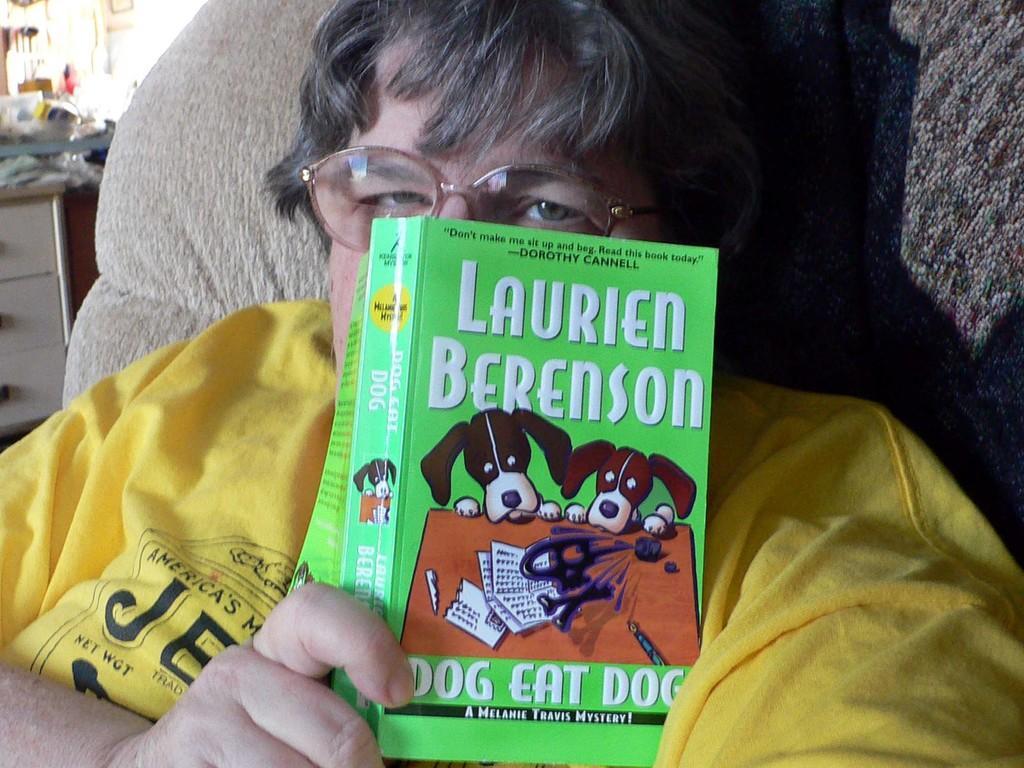Please provide a concise description of this image. In this image we can see a person is sitting, he is wearing yellow color t-shirt and holding one book in his hand, behind we can see one cupboard with few things kept on it. 